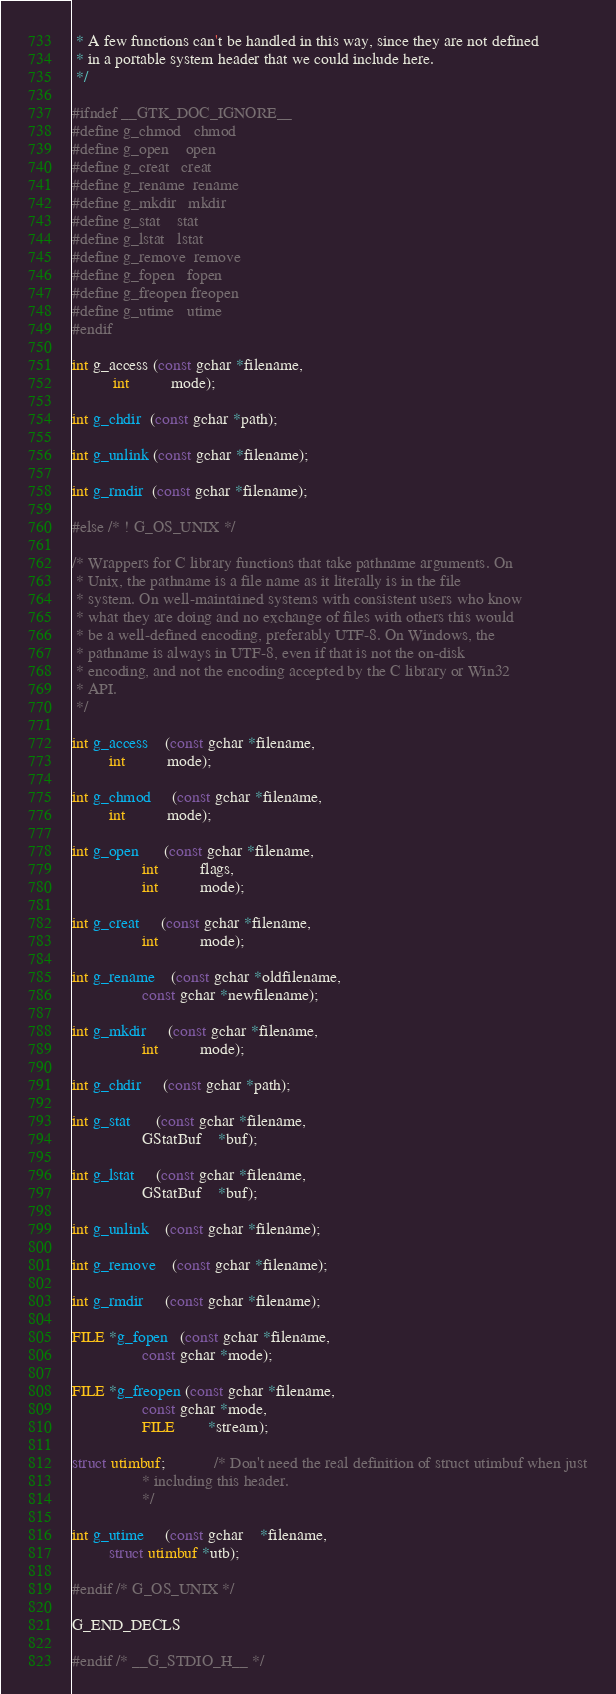<code> <loc_0><loc_0><loc_500><loc_500><_C_> * A few functions can't be handled in this way, since they are not defined
 * in a portable system header that we could include here.
 */

#ifndef __GTK_DOC_IGNORE__
#define g_chmod   chmod
#define g_open    open
#define g_creat   creat
#define g_rename  rename
#define g_mkdir   mkdir
#define g_stat    stat
#define g_lstat   lstat
#define g_remove  remove
#define g_fopen   fopen
#define g_freopen freopen
#define g_utime   utime
#endif

int g_access (const gchar *filename,
	      int          mode);

int g_chdir  (const gchar *path);

int g_unlink (const gchar *filename);

int g_rmdir  (const gchar *filename);

#else /* ! G_OS_UNIX */

/* Wrappers for C library functions that take pathname arguments. On
 * Unix, the pathname is a file name as it literally is in the file
 * system. On well-maintained systems with consistent users who know
 * what they are doing and no exchange of files with others this would
 * be a well-defined encoding, preferably UTF-8. On Windows, the
 * pathname is always in UTF-8, even if that is not the on-disk
 * encoding, and not the encoding accepted by the C library or Win32
 * API.
 */

int g_access    (const gchar *filename,
		 int          mode);

int g_chmod     (const gchar *filename,
		 int          mode);

int g_open      (const gchar *filename,
                 int          flags,
                 int          mode);

int g_creat     (const gchar *filename,
                 int          mode);

int g_rename    (const gchar *oldfilename,
                 const gchar *newfilename);

int g_mkdir     (const gchar *filename,
                 int          mode);

int g_chdir     (const gchar *path);

int g_stat      (const gchar *filename,
                 GStatBuf    *buf);

int g_lstat     (const gchar *filename,
                 GStatBuf    *buf);

int g_unlink    (const gchar *filename);

int g_remove    (const gchar *filename);

int g_rmdir     (const gchar *filename);

FILE *g_fopen   (const gchar *filename,
                 const gchar *mode);

FILE *g_freopen (const gchar *filename,
                 const gchar *mode,
                 FILE        *stream);

struct utimbuf;			/* Don't need the real definition of struct utimbuf when just
				 * including this header.
				 */

int g_utime     (const gchar    *filename,
		 struct utimbuf *utb);

#endif /* G_OS_UNIX */

G_END_DECLS

#endif /* __G_STDIO_H__ */
</code> 